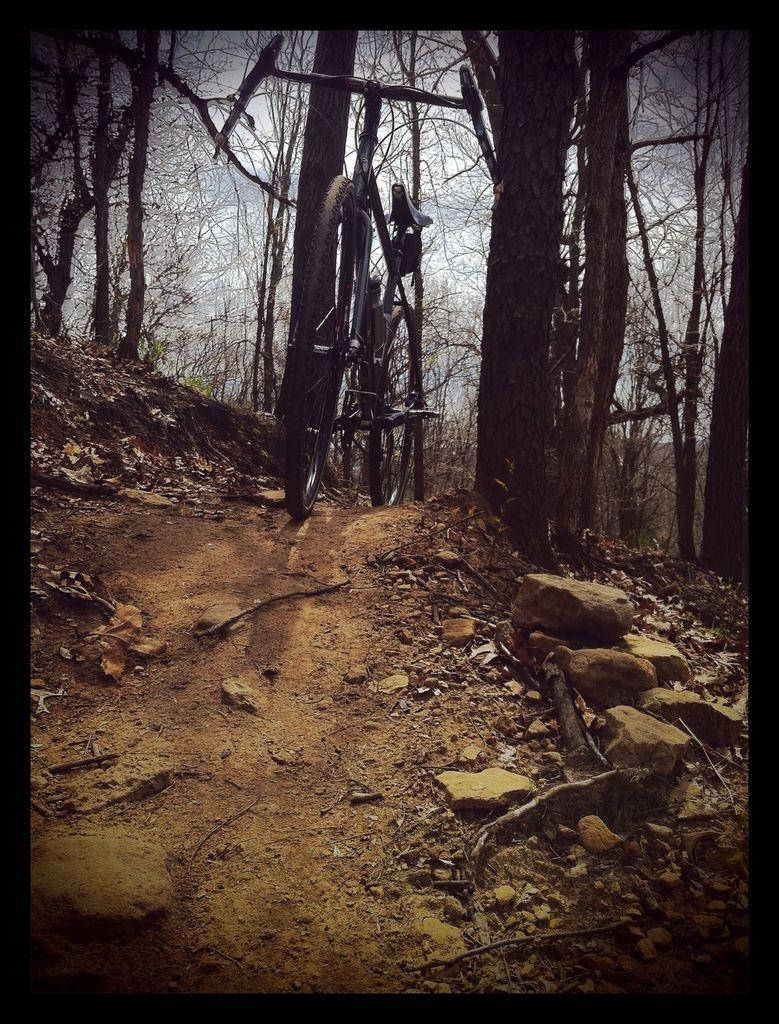What can be seen on the path in the image? There is a bicycle on the path in the image. What objects are present on the surface in the image? There are wooden sticks and rocks on the surface in the image. What can be seen in the background of the image? There are trees in the background of the image. Where is the scarecrow located in the image? There is no scarecrow present in the image. What type of apparel is the baby wearing in the image? There is no baby or apparel present in the image. 